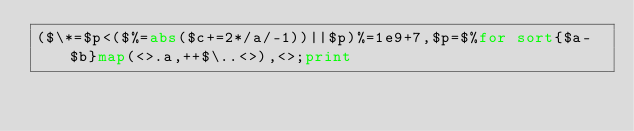<code> <loc_0><loc_0><loc_500><loc_500><_Perl_>($\*=$p<($%=abs($c+=2*/a/-1))||$p)%=1e9+7,$p=$%for sort{$a-$b}map(<>.a,++$\..<>),<>;print</code> 